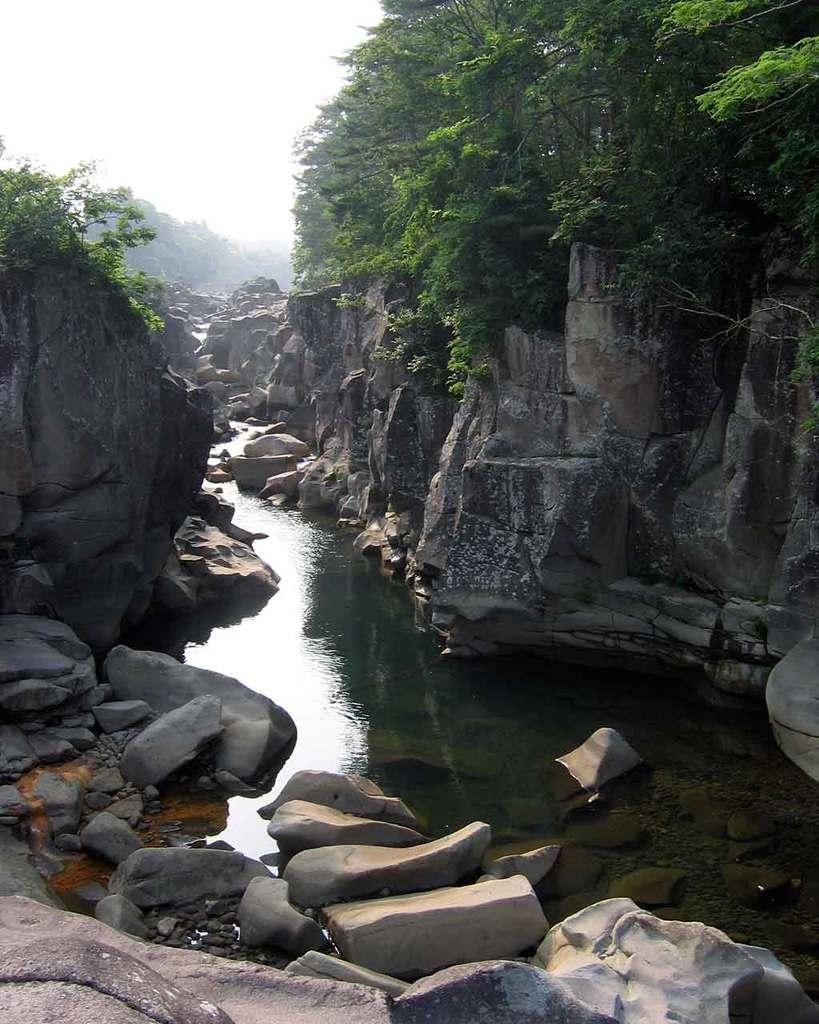What type of body of water is present in the image? There is a lake in the image. What objects can be seen near the lake? There are stones and rocks in the image. What type of vegetation is present in the image? There are trees in the image. What is visible in the background of the image? The sky is visible in the image. How does the doll weigh on the scale in the image? There is no doll or scale present in the image. What type of thrill can be experienced near the lake in the image? The image does not depict any specific activity or thrill near the lake. 